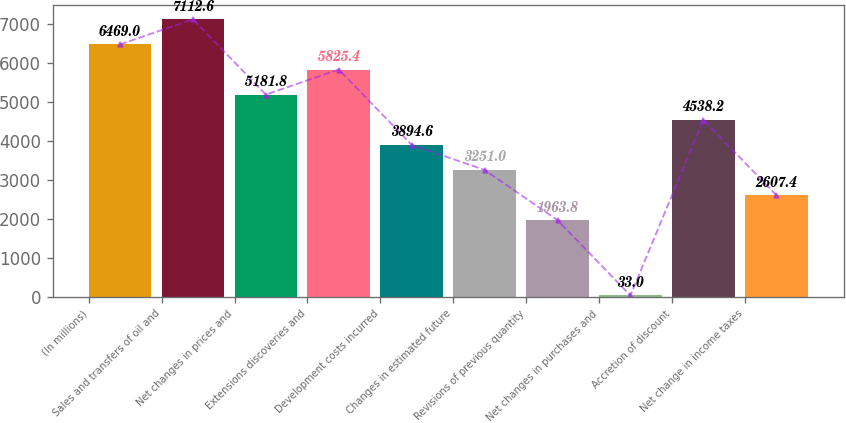<chart> <loc_0><loc_0><loc_500><loc_500><bar_chart><fcel>(In millions)<fcel>Sales and transfers of oil and<fcel>Net changes in prices and<fcel>Extensions discoveries and<fcel>Development costs incurred<fcel>Changes in estimated future<fcel>Revisions of previous quantity<fcel>Net changes in purchases and<fcel>Accretion of discount<fcel>Net change in income taxes<nl><fcel>6469<fcel>7112.6<fcel>5181.8<fcel>5825.4<fcel>3894.6<fcel>3251<fcel>1963.8<fcel>33<fcel>4538.2<fcel>2607.4<nl></chart> 